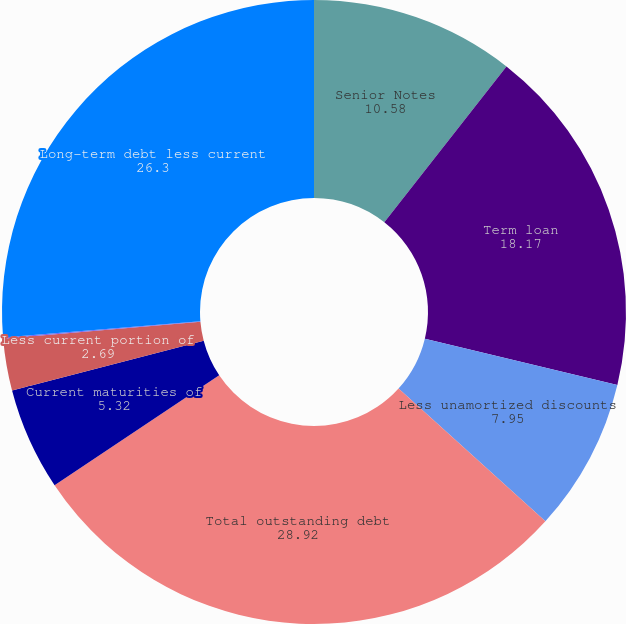Convert chart. <chart><loc_0><loc_0><loc_500><loc_500><pie_chart><fcel>Senior Notes<fcel>Term loan<fcel>Less unamortized discounts<fcel>Total outstanding debt<fcel>Current maturities of<fcel>Less current portion of<fcel>Total short-term debt<fcel>Long-term debt less current<nl><fcel>10.58%<fcel>18.17%<fcel>7.95%<fcel>28.92%<fcel>5.32%<fcel>2.69%<fcel>0.06%<fcel>26.3%<nl></chart> 